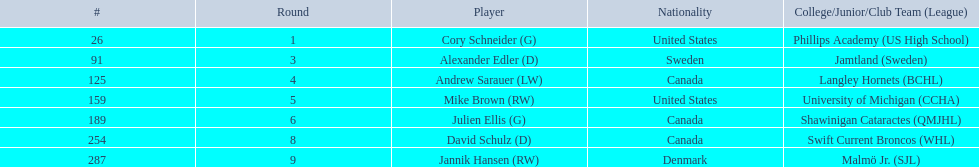What number of players have canada listed as their nationality? 3. 